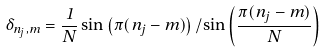<formula> <loc_0><loc_0><loc_500><loc_500>\delta _ { n _ { j } , m } = \frac { 1 } { N } \sin \left ( \pi ( n _ { j } - m ) \right ) / \sin \left ( \frac { \pi ( n _ { j } - m ) } { N } \right )</formula> 